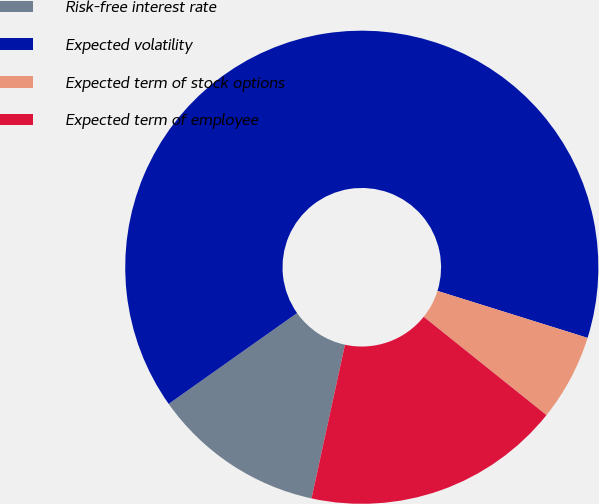<chart> <loc_0><loc_0><loc_500><loc_500><pie_chart><fcel>Risk-free interest rate<fcel>Expected volatility<fcel>Expected term of stock options<fcel>Expected term of employee<nl><fcel>11.79%<fcel>64.62%<fcel>5.92%<fcel>17.66%<nl></chart> 